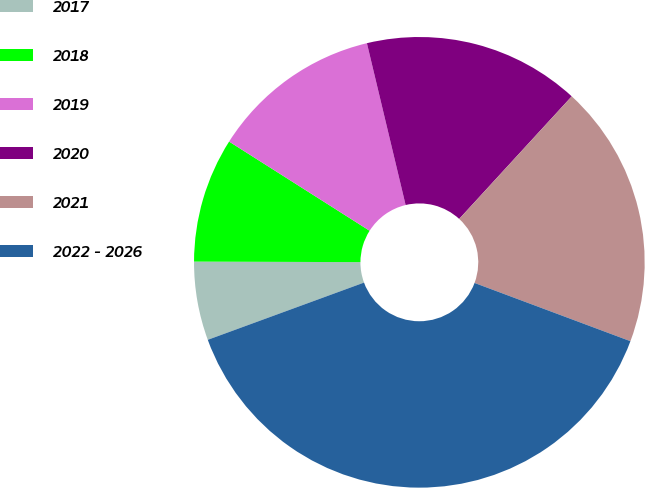<chart> <loc_0><loc_0><loc_500><loc_500><pie_chart><fcel>2017<fcel>2018<fcel>2019<fcel>2020<fcel>2021<fcel>2022 - 2026<nl><fcel>5.64%<fcel>8.95%<fcel>12.26%<fcel>15.56%<fcel>18.87%<fcel>38.72%<nl></chart> 